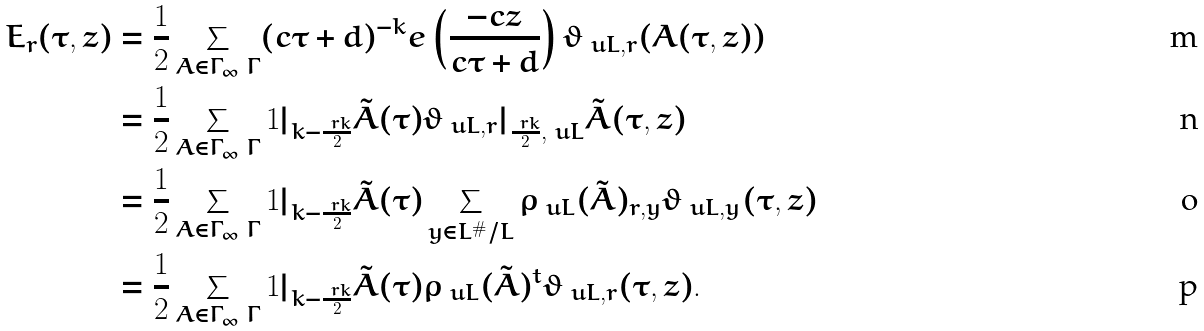<formula> <loc_0><loc_0><loc_500><loc_500>E _ { r } ( \tau , z ) & = \frac { 1 } { 2 } \sum _ { A \in \Gamma _ { \infty } \ \Gamma } ( c \tau + d ) ^ { - k } e \left ( \frac { - c z } { c \tau + d } \right ) \vartheta _ { \ u L , r } ( A ( \tau , z ) ) \\ & = \frac { 1 } { 2 } \sum _ { A \in \Gamma _ { \infty } \ \Gamma } 1 | _ { k - \frac { \ r k } { 2 } } \tilde { A } ( \tau ) \vartheta _ { \ u L , r } | _ { \frac { \ r k } { 2 } , \ u L } \tilde { A } ( \tau , z ) \\ & = \frac { 1 } { 2 } \sum _ { A \in \Gamma _ { \infty } \ \Gamma } 1 | _ { k - \frac { \ r k } { 2 } } \tilde { A } ( \tau ) \sum _ { y \in L ^ { \# } / L } \rho _ { \ u L } ( \tilde { A } ) _ { r , y } \vartheta _ { \ u L , y } ( \tau , z ) \\ & = \frac { 1 } { 2 } \sum _ { A \in \Gamma _ { \infty } \ \Gamma } 1 | _ { k - \frac { \ r k } { 2 } } \tilde { A } ( \tau ) \rho _ { \ u L } ( \tilde { A } ) ^ { t } \vartheta _ { \ u L , r } ( \tau , z ) .</formula> 